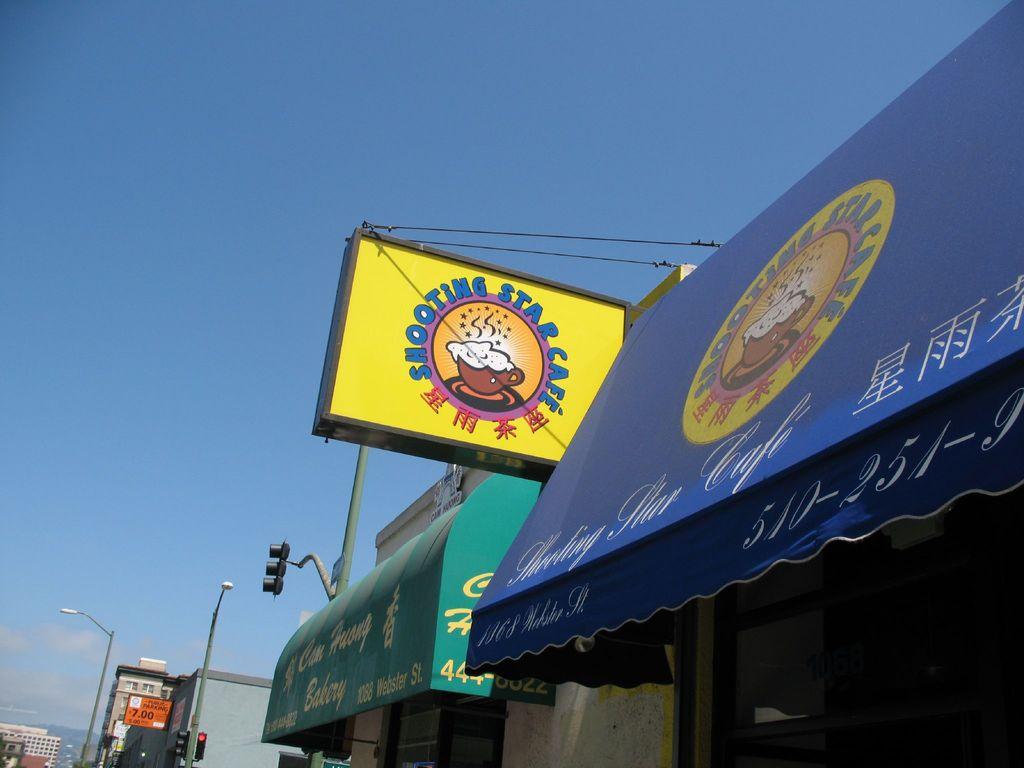What is the area code for the smoothie star cafe?
Keep it short and to the point. 510. 